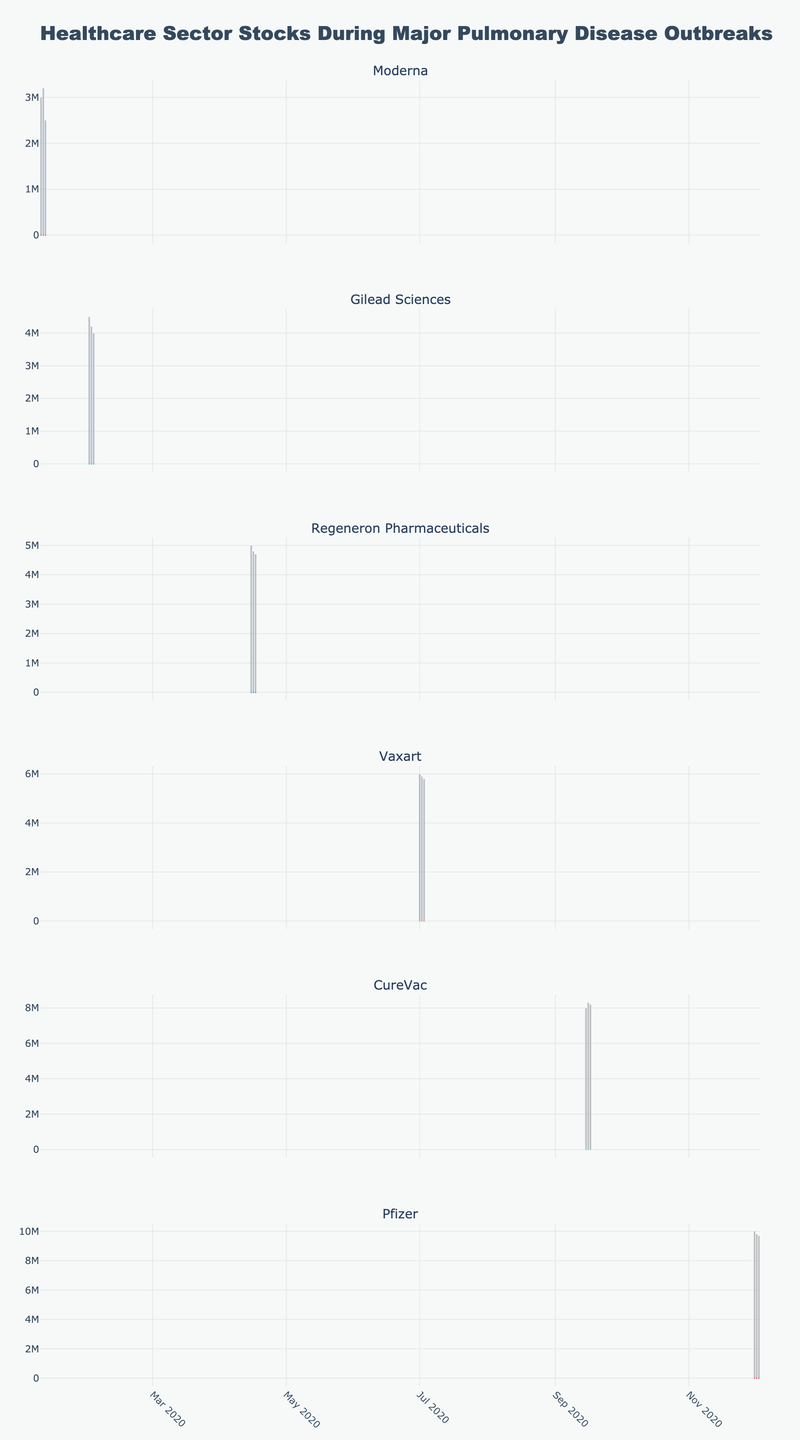How many companies' stock prices are shown in the figure? The subplots are labeled with company names, and each company represents one candlestick plot. Count the distinct subplot titles.
Answer: 5 Which company has the highest closing price in the figure? Identify the highest closing price by examining the highest part of the candlestick body across all plots and correlating it with the company name.
Answer: Pfizer On which company's plot do we observe the largest volume spike? Inspect the bar plots under each candlestick plot for the highest volume bar. Compare the volume bars’ heights across plots, and identify the associated company.
Answer: Pfizer Which company had the most steady increase in closing prices over consecutive days? Look for a continuous upward trend in the rounded end shapes of candlestick bodies across several consecutive days.
Answer: CureVac Between Moderna and Gilead Sciences, which company experienced a greater increase in closing price in January 2020? Calculate the difference between the highest and lowest closing prices in January 2020 for each company. Compare the differences to determine the greater increase.
Answer: Moderna Which company shows the widest range between the highest and lowest prices on any single day? Identify the tallest candlestick bar (distance between the top wick and bottom wick) across all plots, then determine the corresponding company.
Answer: CureVac Which stock had the highest opening price in December 2020? Examine the candlestick plots for December 2020, considering opening prices at the top of the candlestick’s lower body. Compare all December opening prices to find the highest.
Answer: Pfizer What is the difference in closing prices between the first day and the last day for Vaxart? Subtract the closing price on the first represented day from the closing price on the last represented day for Vaxart.
Answer: 10 For Regeneron Pharmaceuticals, what was the average trading volume over the three days in April 2020? Sum the trading volumes of April 15, 16, and 17, then divide by 3 to get the average.
Answer: 4,833,333 